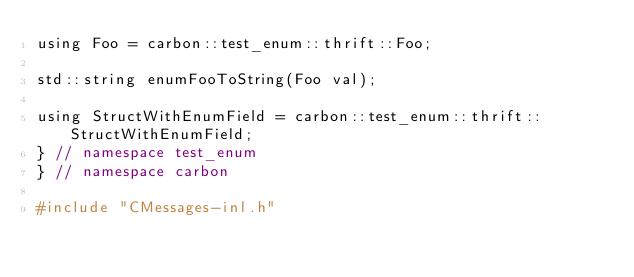<code> <loc_0><loc_0><loc_500><loc_500><_C_>using Foo = carbon::test_enum::thrift::Foo;

std::string enumFooToString(Foo val);

using StructWithEnumField = carbon::test_enum::thrift::StructWithEnumField;
} // namespace test_enum
} // namespace carbon

#include "CMessages-inl.h"
</code> 